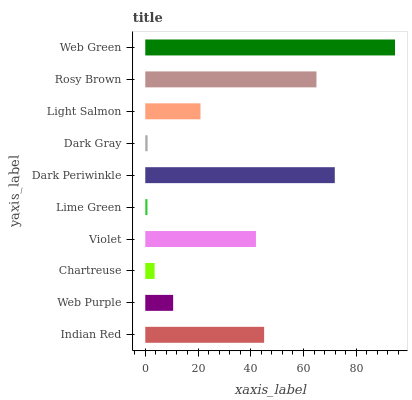Is Lime Green the minimum?
Answer yes or no. Yes. Is Web Green the maximum?
Answer yes or no. Yes. Is Web Purple the minimum?
Answer yes or no. No. Is Web Purple the maximum?
Answer yes or no. No. Is Indian Red greater than Web Purple?
Answer yes or no. Yes. Is Web Purple less than Indian Red?
Answer yes or no. Yes. Is Web Purple greater than Indian Red?
Answer yes or no. No. Is Indian Red less than Web Purple?
Answer yes or no. No. Is Violet the high median?
Answer yes or no. Yes. Is Light Salmon the low median?
Answer yes or no. Yes. Is Dark Gray the high median?
Answer yes or no. No. Is Violet the low median?
Answer yes or no. No. 